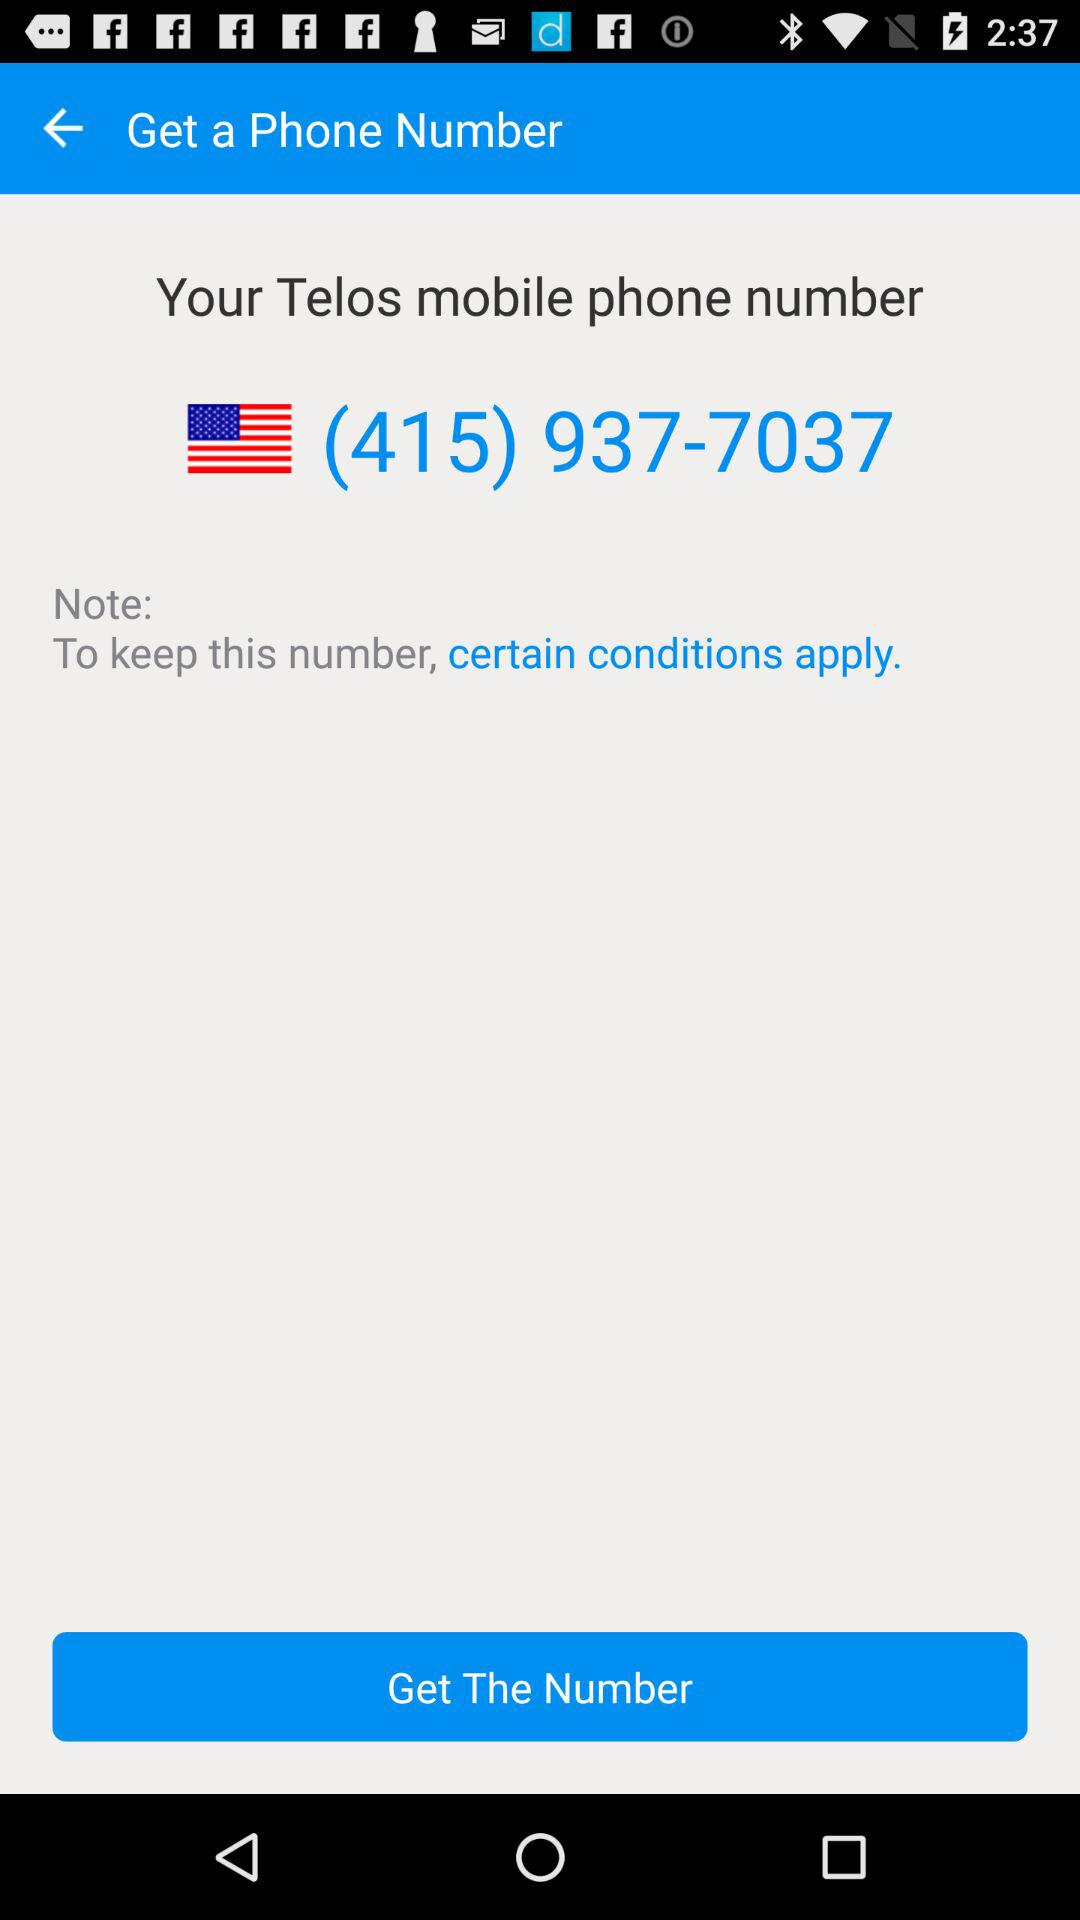What is the given phone number? The given phone number is (415) 937-7037. 